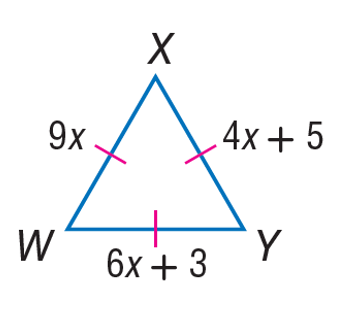Answer the mathemtical geometry problem and directly provide the correct option letter.
Question: Find the length of W Y.
Choices: A: 4 B: 5 C: 6 D: 9 D 